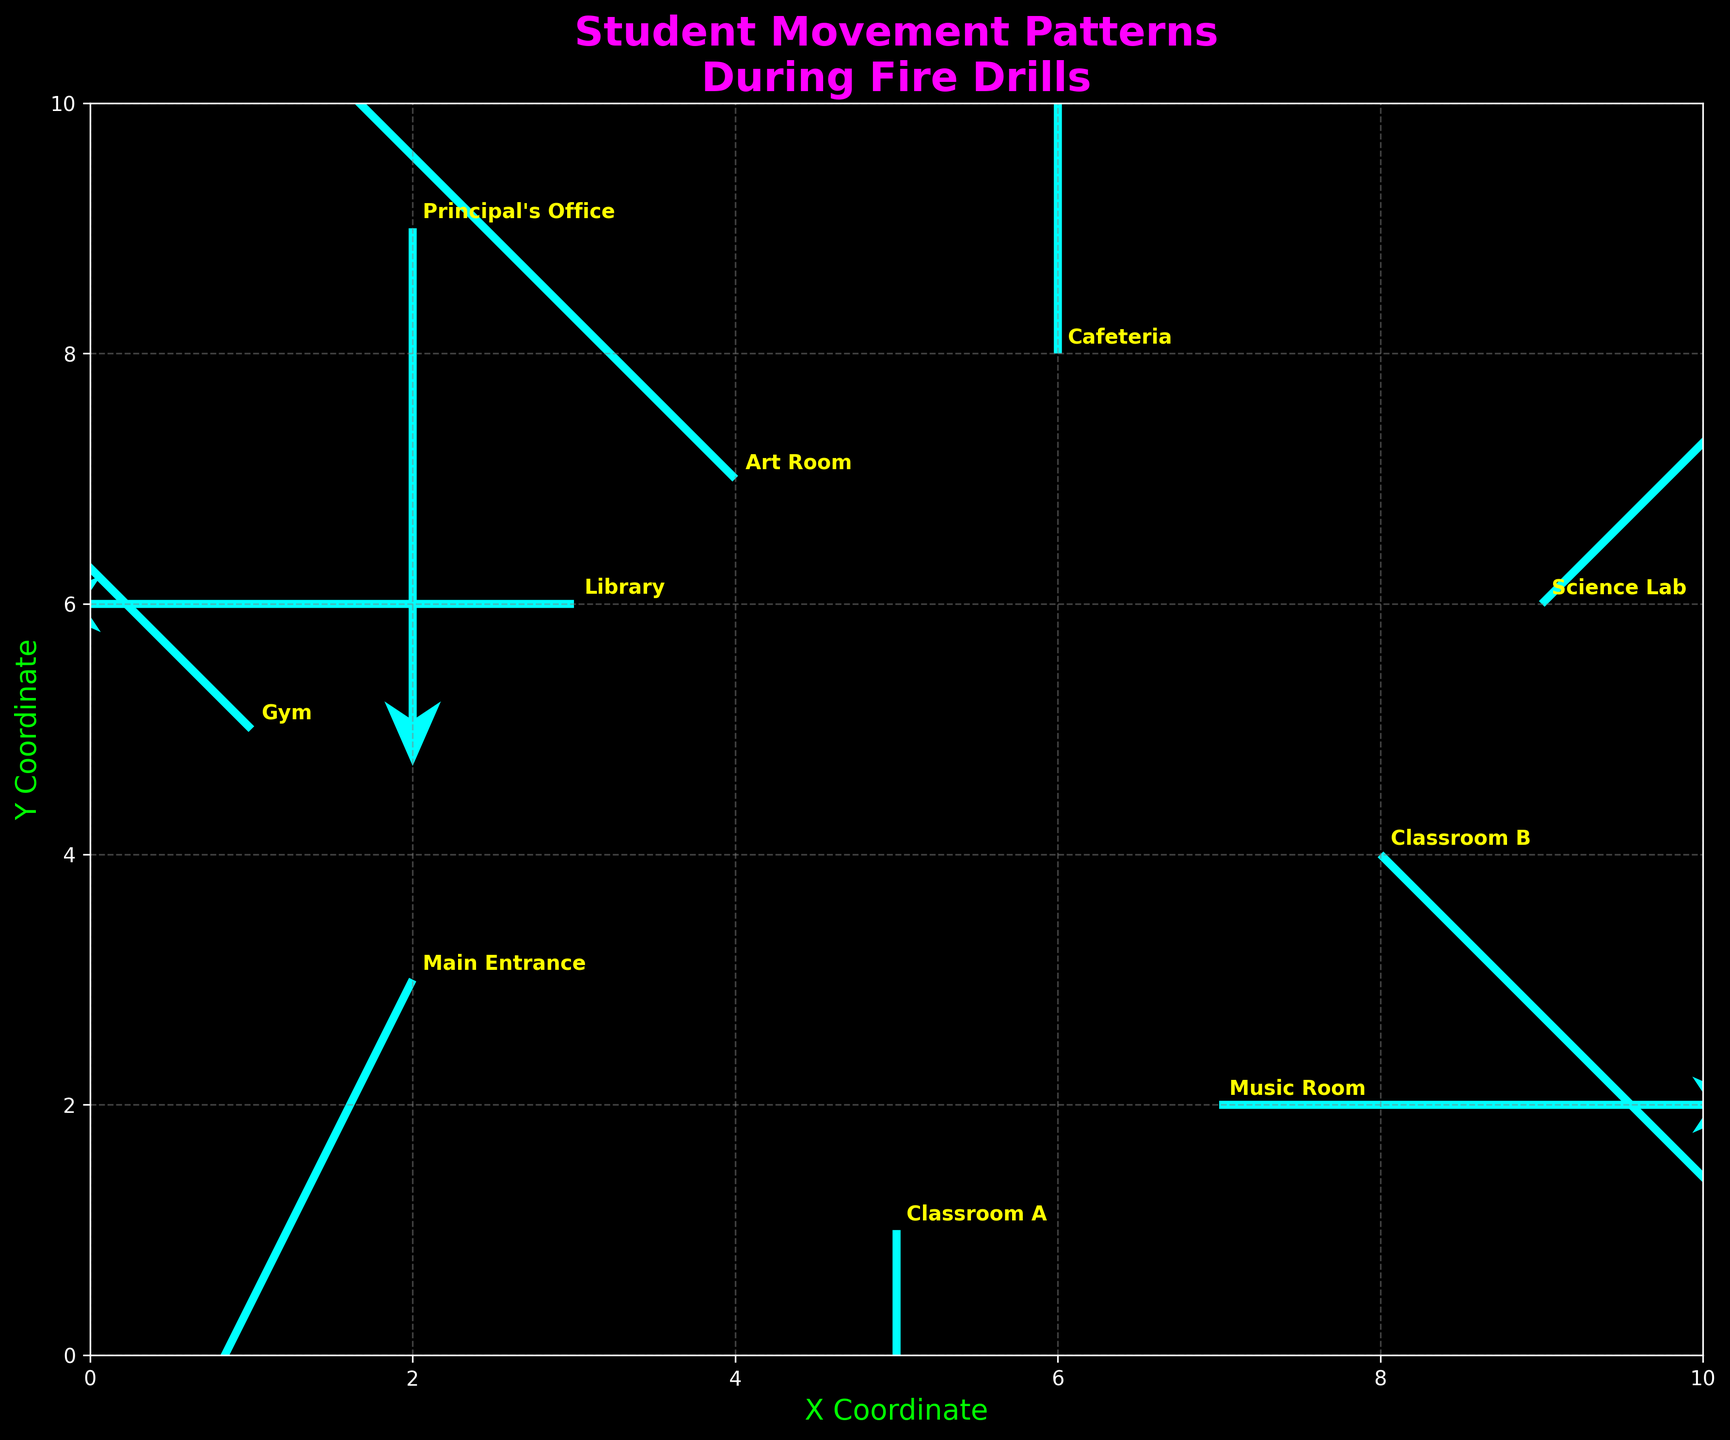What's the title of the figure? The title is displayed at the top of the figure, reading in bold and an eye-catching color.
Answer: Student Movement Patterns During Fire Drills What are the axis labels of the figure? The x-axis label is located at the bottom of the plot, and the y-axis label is located on the left side of the plot.
Answer: X Coordinate and Y Coordinate How many labeled points are there in the figure? Each point in the plot is labeled with a text annotation, making it easy to count them.
Answer: 10 Which point has the highest y-coordinate? We look at all the y-coordinate values labeled on the plot and identify the maximum one.
Answer: Principal's Office What direction do students from the Gym move towards? We examine the direction of the arrow originating from the Gym label, which points in the movement direction.
Answer: Towards the upper left Which locations have no vertical movement of students? We find points where the v component is zero, indicating no vertical movement, and check their labels.
Answer: Library and Music Room What is the average x-coordinate of all points? Sum all x-coordinates and divide by the number of points: (2 + 5 + 8 + 3 + 6 + 1 + 7 + 4 + 9 + 2) / 10 = 4.7
Answer: 4.7 Which point has the longest arrow, indicating the greatest movement distance? Calculate the magnitude of each vector (using the formula √(u² + v²)) and identify the largest one.
Answer: Main Entrance How many points indicate movement towards the right? Check each arrow's direction: Students move right if u > 0, and count these arrows.
Answer: 3 Where do students from Classroom A move to during the drill? Observe the direction and magnitude of the arrow originating from Classroom A. It indicates movement downward only.
Answer: Downward only (one unit) 